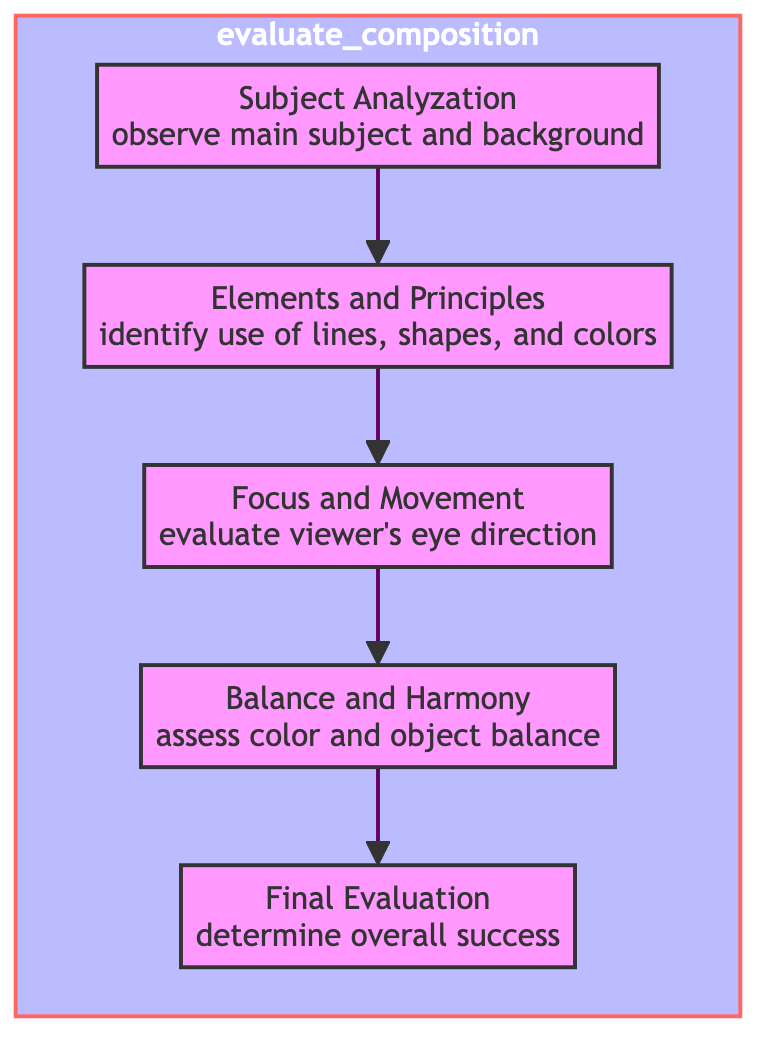What is the first step in the evaluation process? The diagram shows that the evaluation process begins with the "Subject Analyzation" step where one observes the main subject and background. This is represented as the bottom node in the flowchart.
Answer: Subject Analyzation How many steps are in the evaluation flowchart? By counting the nodes in the flowchart, there are five steps, including the final evaluation. These steps are Subject Analyzation, Elements and Principles, Focus and Movement, Balance and Harmony, and Final Evaluation.
Answer: Five What activity is associated with the "Balance and Harmony" step? According to the diagram, the activity linked to the "Balance and Harmony" step is "assess color and object balance." This can be found by identifying the connection to this specific step in the flowchart.
Answer: Assess color and object balance What is the final step in the process? The last node in the flowchart is labeled "Final Evaluation," which indicates that determining overall success is the concluding action in the evaluation of composition.
Answer: Final Evaluation Which step follows "Focus and Movement"? The diagram clearly shows that the step following "Focus and Movement" is "Balance and Harmony." This relationship can be traced by following the arrows connecting the flow of steps.
Answer: Balance and Harmony Explain the relationship between "Elements and Principles" and "Focus and Movement." The flowchart indicates that after identifying the use of lines, shapes, and colors in "Elements and Principles," the next action is to evaluate the viewer's eye direction in "Focus and Movement." This is a sequential relationship as depicted in the diagram.
Answer: Sequential What is the main activity involved in "Elements and Principles"? The main activity indicated in the "Elements and Principles" step is to "identify use of lines, shapes, and colors." This can be confirmed by examining the specific activity listed under this node in the flowchart.
Answer: Identify use of lines, shapes, and colors How does the flowchart represent the evaluation of a painting's composition? The flowchart systematically organizes the steps in evaluating composition, starting from observing the subject and moving through elements and principles, focus, balance, and culminating in a final evaluation of overall success. This orderly structure indicates a process that builds on each previous step.
Answer: Systematic organization What do all steps in the flowchart lead to? Each step in the flowchart ultimately leads to the "Final Evaluation," indicating that all preceding steps contribute to assessing the overall success of a painting's composition. This is a key aspect of the flowchart's design.
Answer: Final Evaluation 